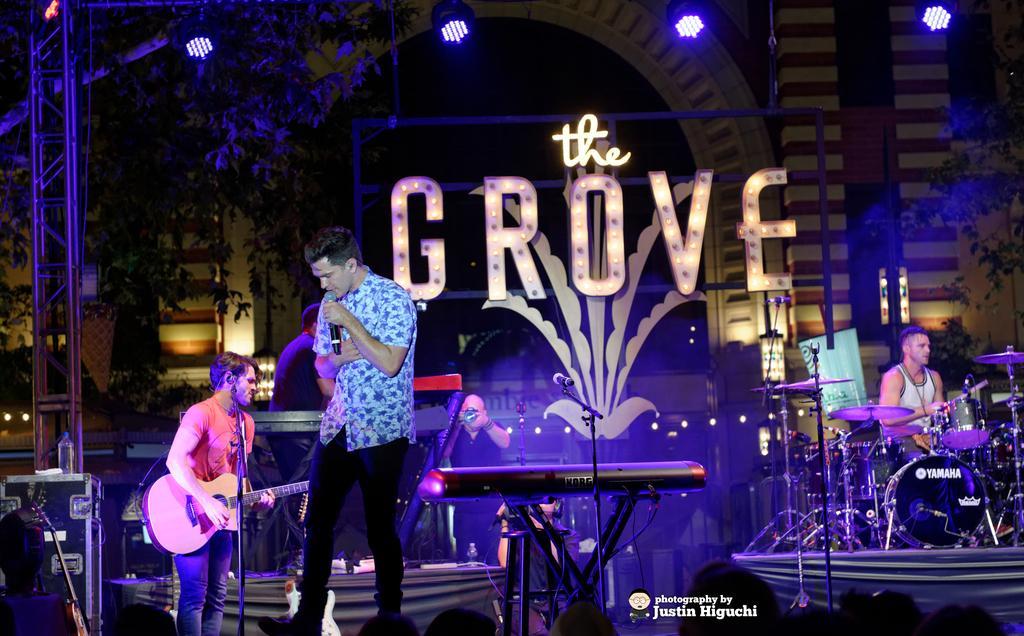Could you give a brief overview of what you see in this image? In this image there is a man standing on the stage and singing in microphone, behind him there are other people and playing musical instruments. 